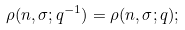<formula> <loc_0><loc_0><loc_500><loc_500>\rho ( n , \sigma ; q ^ { - 1 } ) = \rho ( n , \sigma ; q ) ;</formula> 